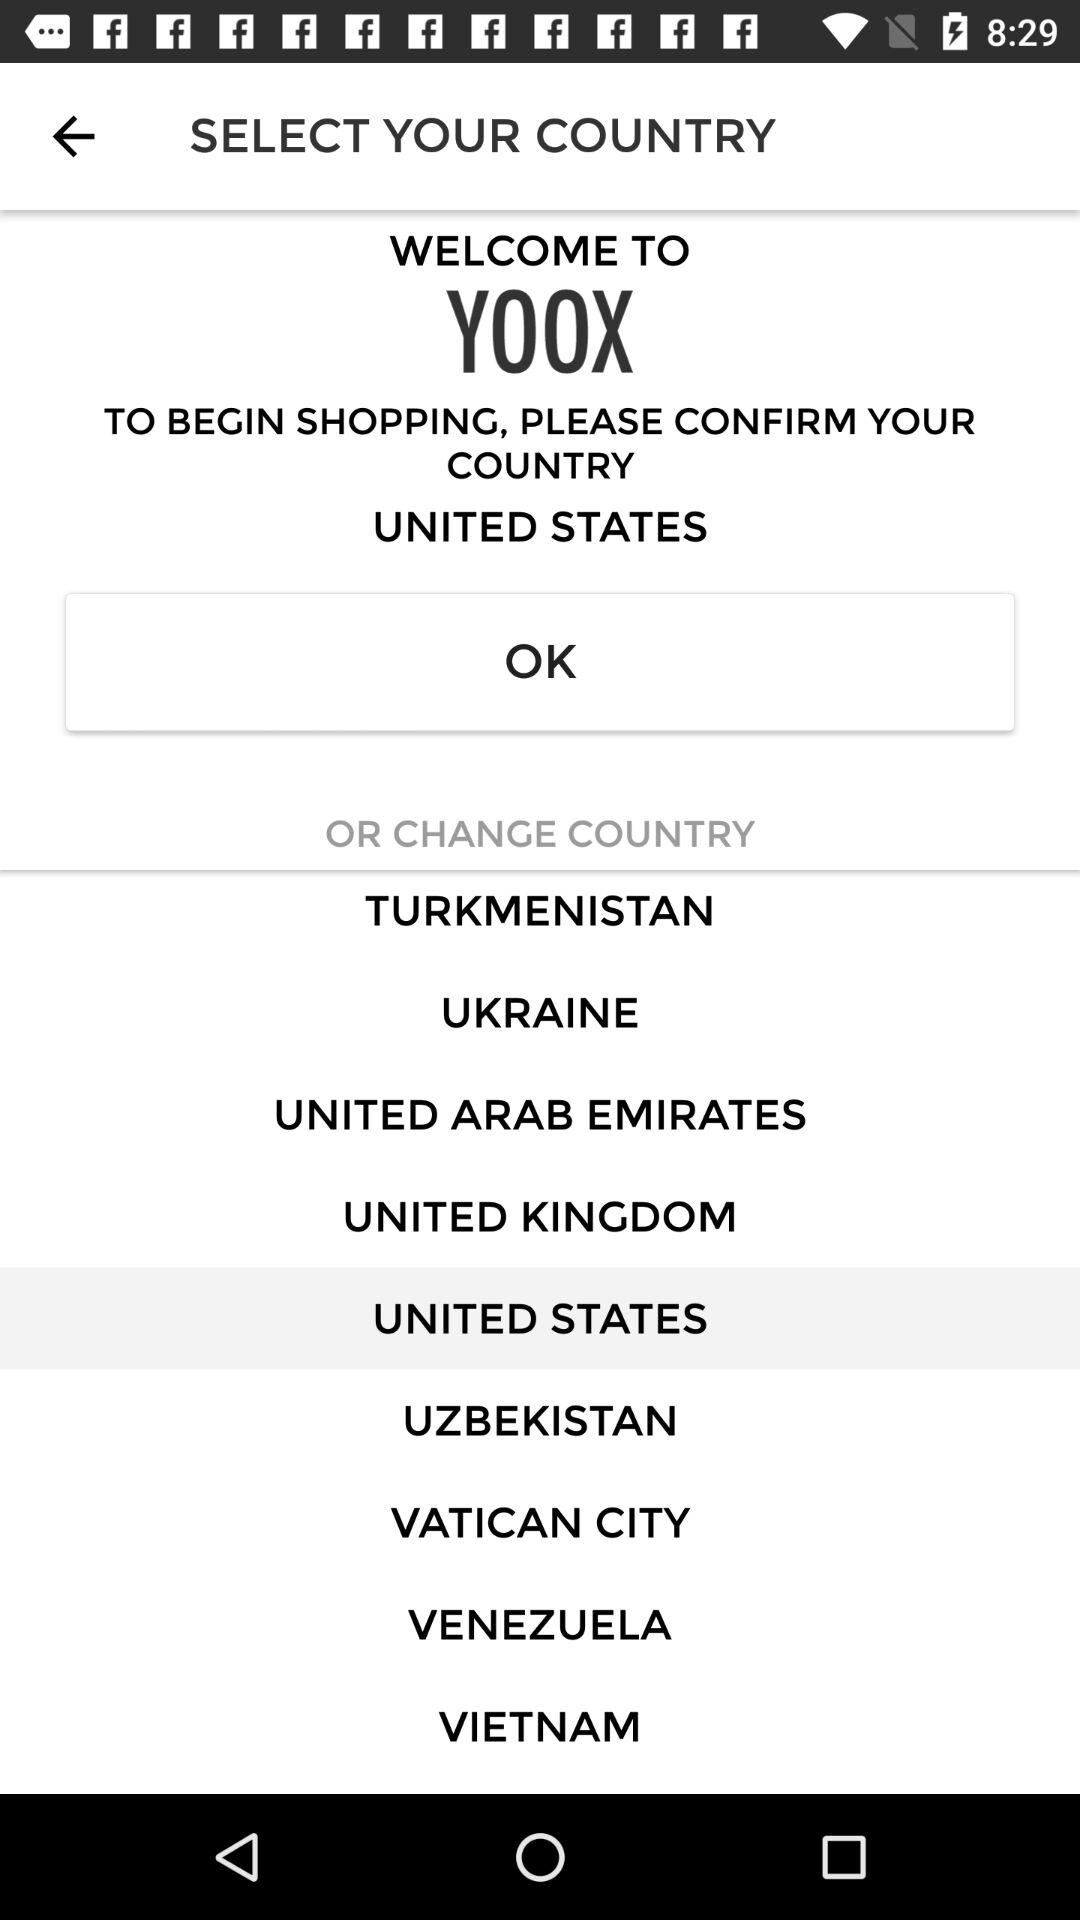What do we need to do to begin shopping? You need to confirm your country or change the country to begin shopping. 